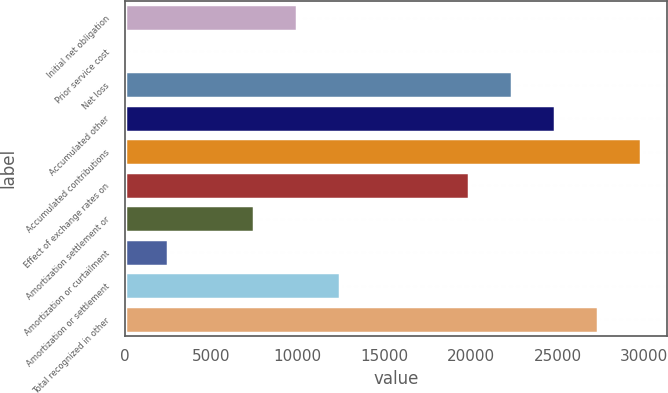Convert chart. <chart><loc_0><loc_0><loc_500><loc_500><bar_chart><fcel>Initial net obligation<fcel>Prior service cost<fcel>Net loss<fcel>Accumulated other<fcel>Accumulated contributions<fcel>Effect of exchange rates on<fcel>Amortization settlement or<fcel>Amortization or curtailment<fcel>Amortization or settlement<fcel>Total recognized in other<nl><fcel>9950.6<fcel>7<fcel>22380.1<fcel>24866<fcel>29837.8<fcel>19894.2<fcel>7464.7<fcel>2492.9<fcel>12436.5<fcel>27351.9<nl></chart> 